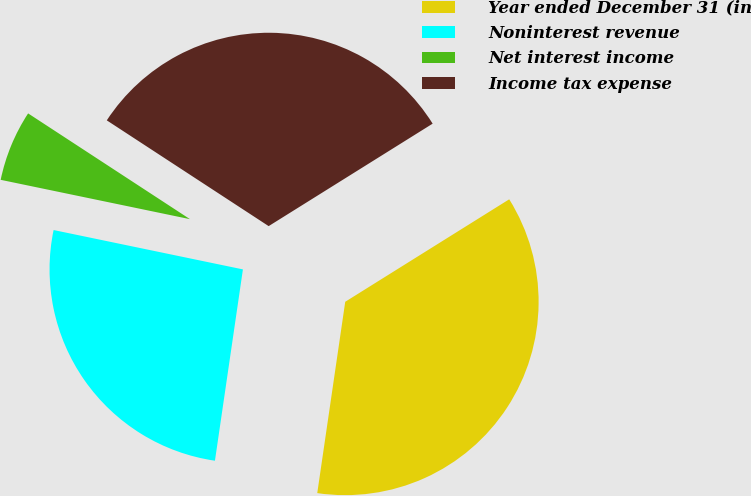Convert chart to OTSL. <chart><loc_0><loc_0><loc_500><loc_500><pie_chart><fcel>Year ended December 31 (in<fcel>Noninterest revenue<fcel>Net interest income<fcel>Income tax expense<nl><fcel>36.2%<fcel>25.95%<fcel>5.95%<fcel>31.9%<nl></chart> 